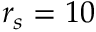Convert formula to latex. <formula><loc_0><loc_0><loc_500><loc_500>r _ { s } = 1 0</formula> 